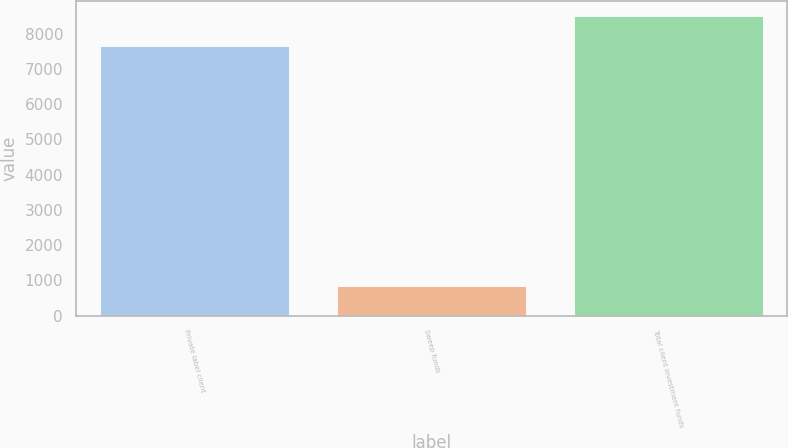<chart> <loc_0><loc_0><loc_500><loc_500><bar_chart><fcel>Private label client<fcel>Sweep funds<fcel>Total client investment funds<nl><fcel>7642.1<fcel>853.2<fcel>8495.3<nl></chart> 